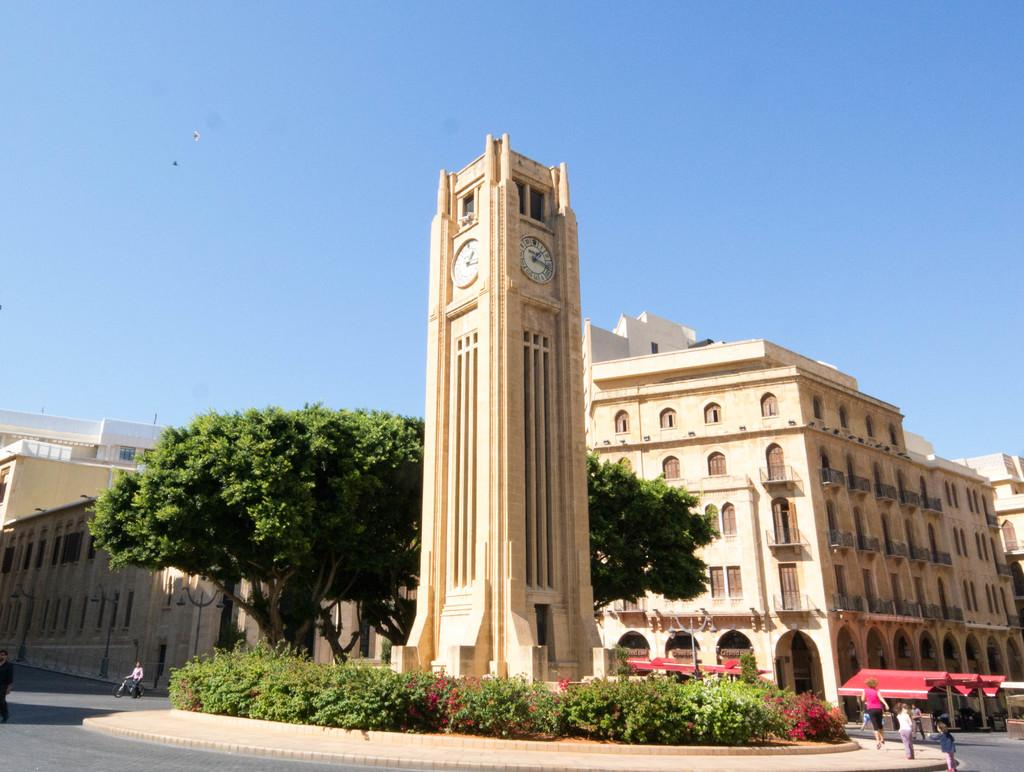<image>
Offer a succinct explanation of the picture presented. A clock tower with the time at about 1:15 PM. 